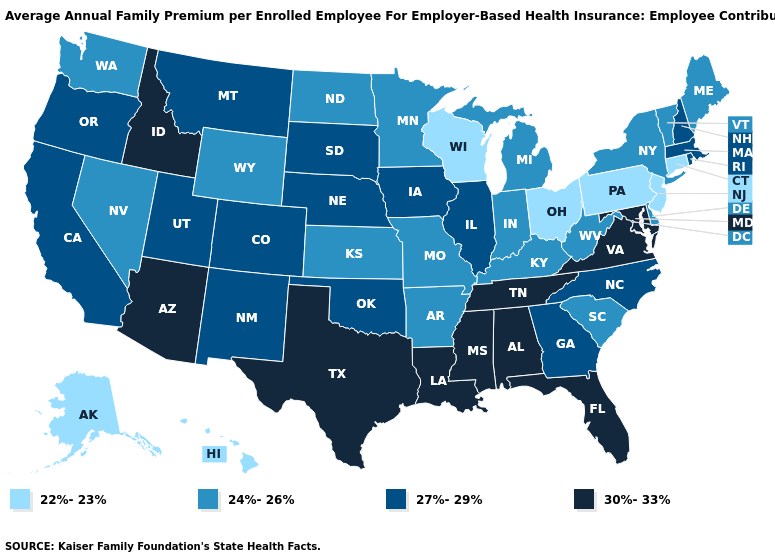What is the highest value in the MidWest ?
Concise answer only. 27%-29%. Does Connecticut have a higher value than Oregon?
Write a very short answer. No. Among the states that border Nebraska , which have the lowest value?
Write a very short answer. Kansas, Missouri, Wyoming. What is the value of Alabama?
Give a very brief answer. 30%-33%. Does North Dakota have the lowest value in the MidWest?
Concise answer only. No. What is the lowest value in the MidWest?
Concise answer only. 22%-23%. Among the states that border Delaware , which have the highest value?
Be succinct. Maryland. Among the states that border Connecticut , does New York have the highest value?
Keep it brief. No. Among the states that border West Virginia , does Ohio have the lowest value?
Give a very brief answer. Yes. Among the states that border North Carolina , does Tennessee have the lowest value?
Be succinct. No. What is the value of Idaho?
Short answer required. 30%-33%. What is the highest value in the USA?
Concise answer only. 30%-33%. Name the states that have a value in the range 30%-33%?
Short answer required. Alabama, Arizona, Florida, Idaho, Louisiana, Maryland, Mississippi, Tennessee, Texas, Virginia. Name the states that have a value in the range 22%-23%?
Give a very brief answer. Alaska, Connecticut, Hawaii, New Jersey, Ohio, Pennsylvania, Wisconsin. Does the map have missing data?
Give a very brief answer. No. 